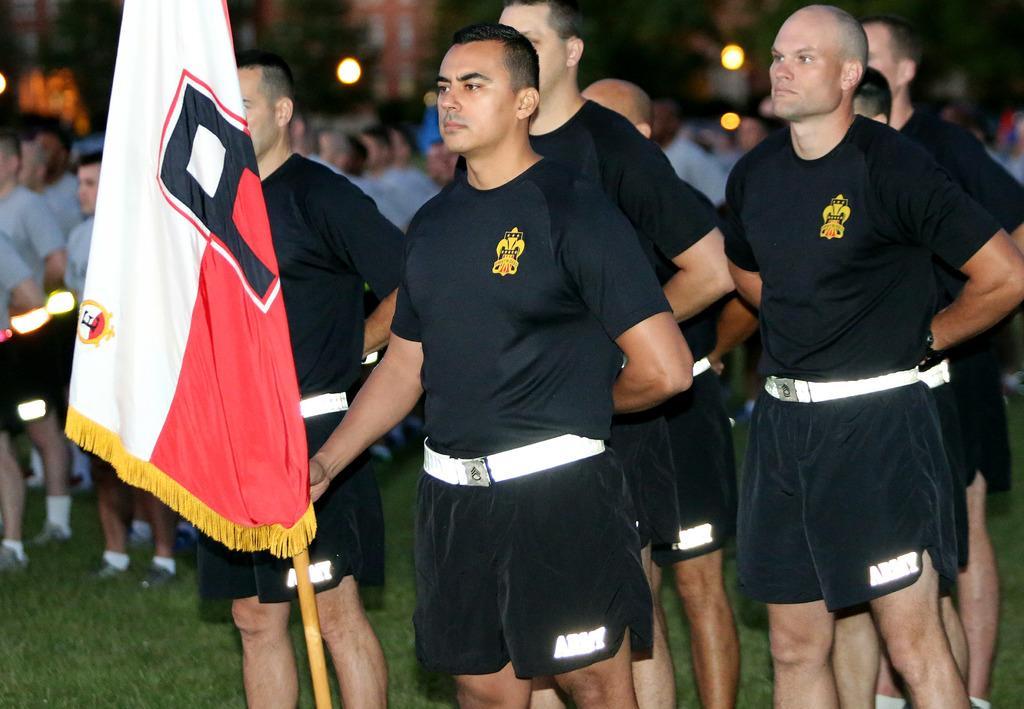Describe this image in one or two sentences. In this picture I can see few men standing in front and I see that they're wearing same dress and I see a man is holding a flag. In the background I can see few people and I see the grass. I can also see few lights and I see that it is blurred in the background. 